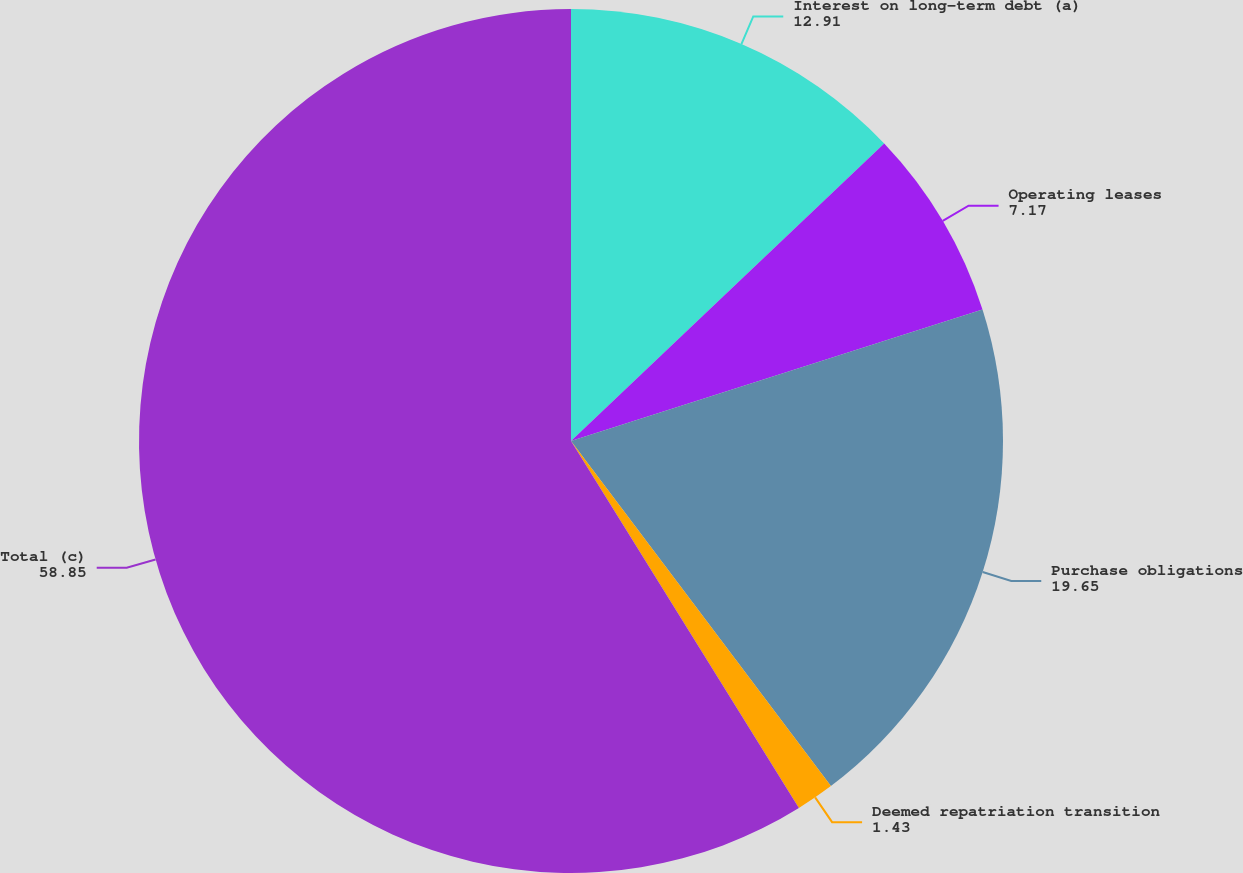<chart> <loc_0><loc_0><loc_500><loc_500><pie_chart><fcel>Interest on long-term debt (a)<fcel>Operating leases<fcel>Purchase obligations<fcel>Deemed repatriation transition<fcel>Total (c)<nl><fcel>12.91%<fcel>7.17%<fcel>19.65%<fcel>1.43%<fcel>58.85%<nl></chart> 